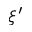Convert formula to latex. <formula><loc_0><loc_0><loc_500><loc_500>\xi ^ { \prime }</formula> 